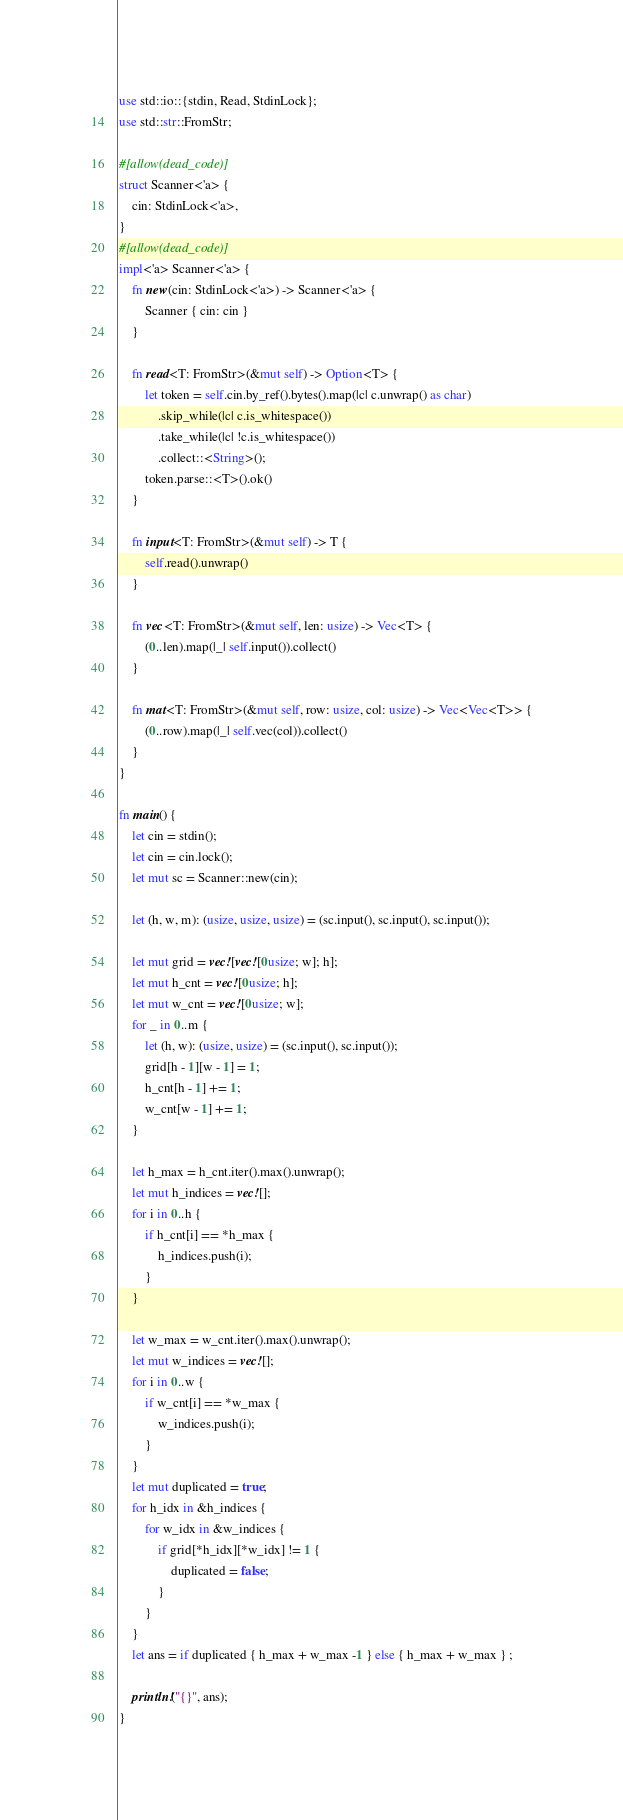<code> <loc_0><loc_0><loc_500><loc_500><_Rust_>use std::io::{stdin, Read, StdinLock};
use std::str::FromStr;

#[allow(dead_code)]
struct Scanner<'a> {
    cin: StdinLock<'a>,
}
#[allow(dead_code)]
impl<'a> Scanner<'a> {
    fn new(cin: StdinLock<'a>) -> Scanner<'a> {
        Scanner { cin: cin }
    }

    fn read<T: FromStr>(&mut self) -> Option<T> {
        let token = self.cin.by_ref().bytes().map(|c| c.unwrap() as char)
            .skip_while(|c| c.is_whitespace())
            .take_while(|c| !c.is_whitespace())
            .collect::<String>();
        token.parse::<T>().ok()
    }

    fn input<T: FromStr>(&mut self) -> T {
        self.read().unwrap()
    }

    fn vec<T: FromStr>(&mut self, len: usize) -> Vec<T> {
        (0..len).map(|_| self.input()).collect()
    }

    fn mat<T: FromStr>(&mut self, row: usize, col: usize) -> Vec<Vec<T>> {
        (0..row).map(|_| self.vec(col)).collect()
    }
}

fn main() {
    let cin = stdin();
    let cin = cin.lock();
    let mut sc = Scanner::new(cin);

    let (h, w, m): (usize, usize, usize) = (sc.input(), sc.input(), sc.input());

    let mut grid = vec![vec![0usize; w]; h];
    let mut h_cnt = vec![0usize; h];
    let mut w_cnt = vec![0usize; w];
    for _ in 0..m {
        let (h, w): (usize, usize) = (sc.input(), sc.input());
        grid[h - 1][w - 1] = 1;
        h_cnt[h - 1] += 1;
        w_cnt[w - 1] += 1;
    }

    let h_max = h_cnt.iter().max().unwrap();
    let mut h_indices = vec![];
    for i in 0..h {
        if h_cnt[i] == *h_max {
            h_indices.push(i);
        }
    }

    let w_max = w_cnt.iter().max().unwrap();
    let mut w_indices = vec![];
    for i in 0..w {
        if w_cnt[i] == *w_max {
            w_indices.push(i);
        }
    }
    let mut duplicated = true;
    for h_idx in &h_indices {
        for w_idx in &w_indices {
            if grid[*h_idx][*w_idx] != 1 {
                duplicated = false;
            }
        }
    }
    let ans = if duplicated { h_max + w_max -1 } else { h_max + w_max } ;

    println!("{}", ans);
}
</code> 